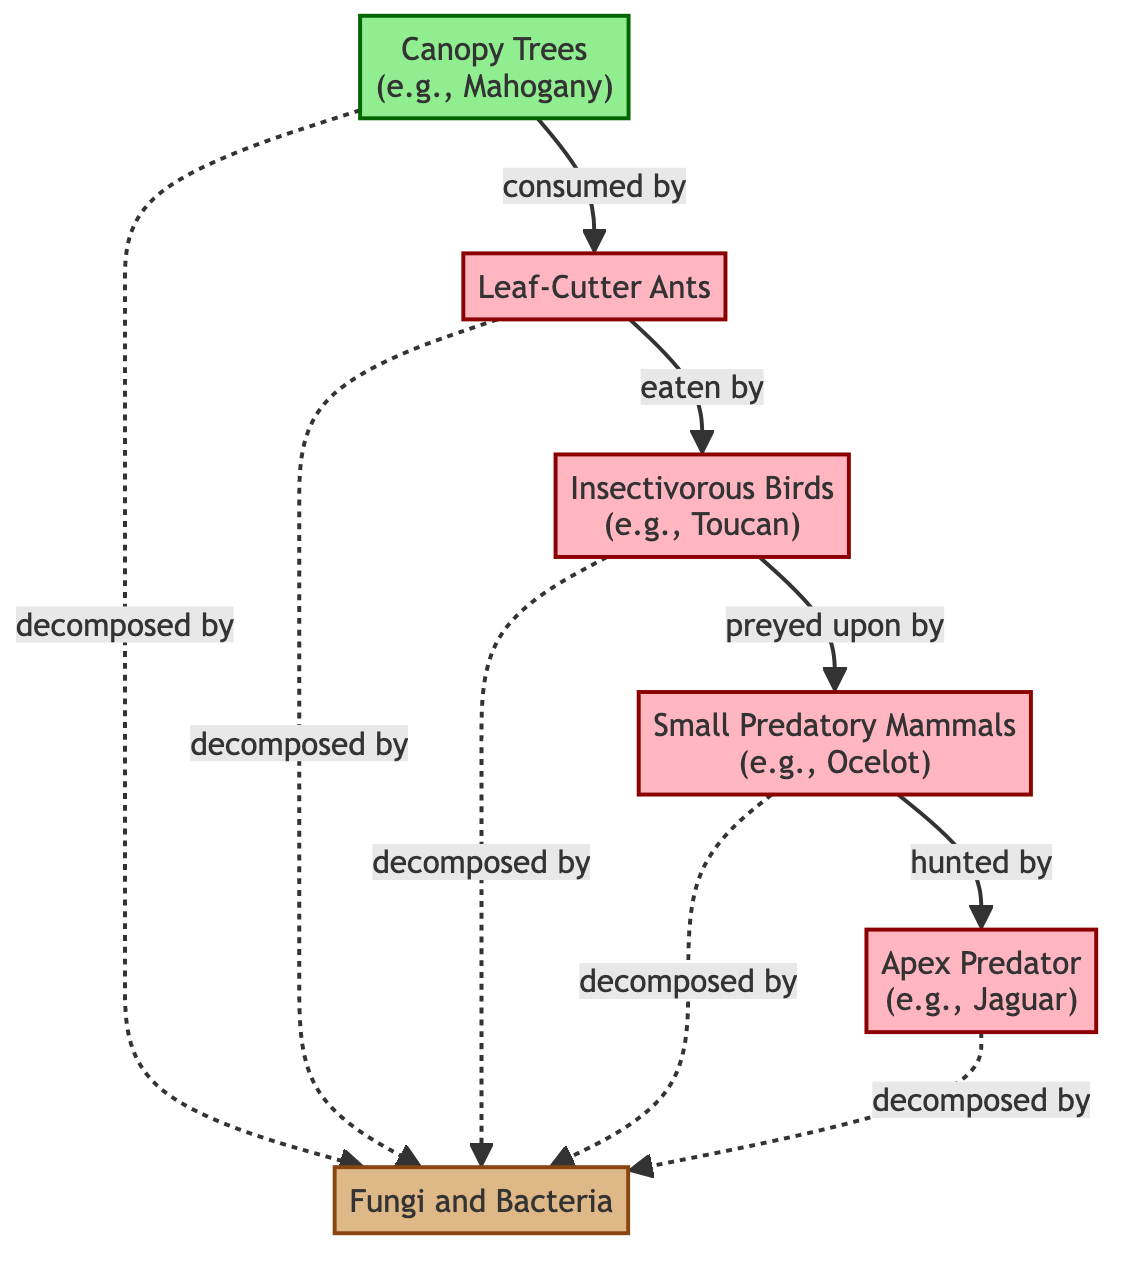What is the primary producer in this food chain? The diagram identifies "Canopy Trees (e.g., Mahogany)" as the primary producer, which is the first trophic level in the food chain.
Answer: Canopy Trees How many consumer levels are present in the diagram? By examining the diagram, there are four levels of consumers: herbivore, secondary consumer, tertiary consumer, and quaternary consumer.
Answer: Four Who is the apex predator in this food chain? The diagram explicitly labels "Apex Predator (e.g., Jaguar)" as the quaternary consumer, which occupies the top level in the food chain.
Answer: Apex Predator What do decomposers work on in this food chain? The diagram shows that decomposers (Fungi and Bacteria) work on the dead matter from the primary producer, herbivore, secondary consumer, tertiary consumer, and quaternary consumer, indicated by the dashed lines connecting them to the decomposer node.
Answer: All organisms Which consumer level prey on the secondary consumer? The diagram indicates that the tertiary consumer, represented by "Small Predatory Mammals (e.g., Ocelot)," preys on the secondary consumer (Insectivorous Birds).
Answer: Tertiary Consumer How many total nodes are represented in this diagram? The diagram shows a total of six distinct nodes: one primary producer, one decomposer, and four consumer types. By counting these, we confirm the total count.
Answer: Six What is the relationship between the herbivore and the decomposer? According to the diagram, there is a dashed line representing the relationship where the herbivore, after dying, contributes to the decomposer's role, showing a connection between living organisms and decomposers.
Answer: Decomposed by Which organism comes after the herbivore in this food chain? The flow of the arrows indicates that the primary producer is consumed by the herbivore, and then the herbivore itself is eaten by the secondary consumer, which comes next in the sequence.
Answer: Secondary Consumer 